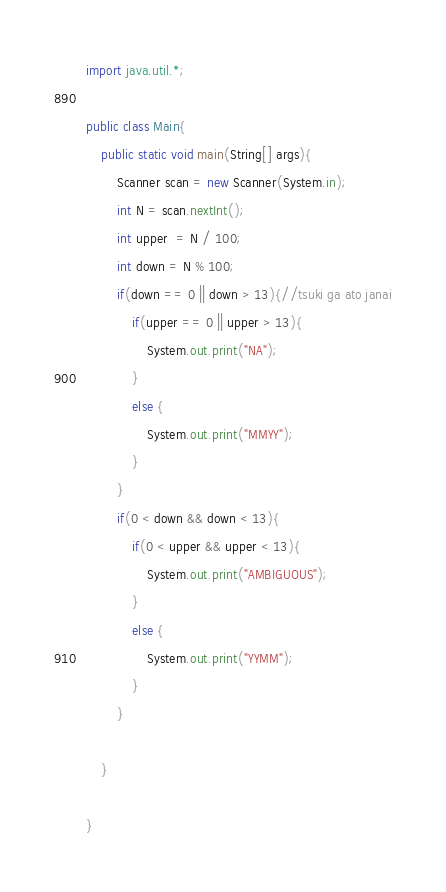<code> <loc_0><loc_0><loc_500><loc_500><_Java_>import java.util.*;
 
public class Main{
	public static void main(String[] args){
    	Scanner scan = new Scanner(System.in);
      	int N = scan.nextInt();
      	int upper  = N / 100;
      	int down = N % 100;
      	if(down == 0 || down > 13){//tsuki ga ato janai
          	if(upper == 0 || upper > 13){
        		System.out.print("NA");
            }
          	else {
            	System.out.print("MMYY");
            }
        }
      	if(0 < down && down < 13){
        	if(0 < upper && upper < 13){
            	System.out.print("AMBIGUOUS");
            }
          	else {
            	System.out.print("YYMM");
            }
        }
      	
    }
 
}</code> 